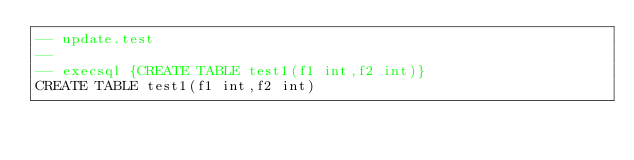<code> <loc_0><loc_0><loc_500><loc_500><_SQL_>-- update.test
-- 
-- execsql {CREATE TABLE test1(f1 int,f2 int)}
CREATE TABLE test1(f1 int,f2 int)</code> 